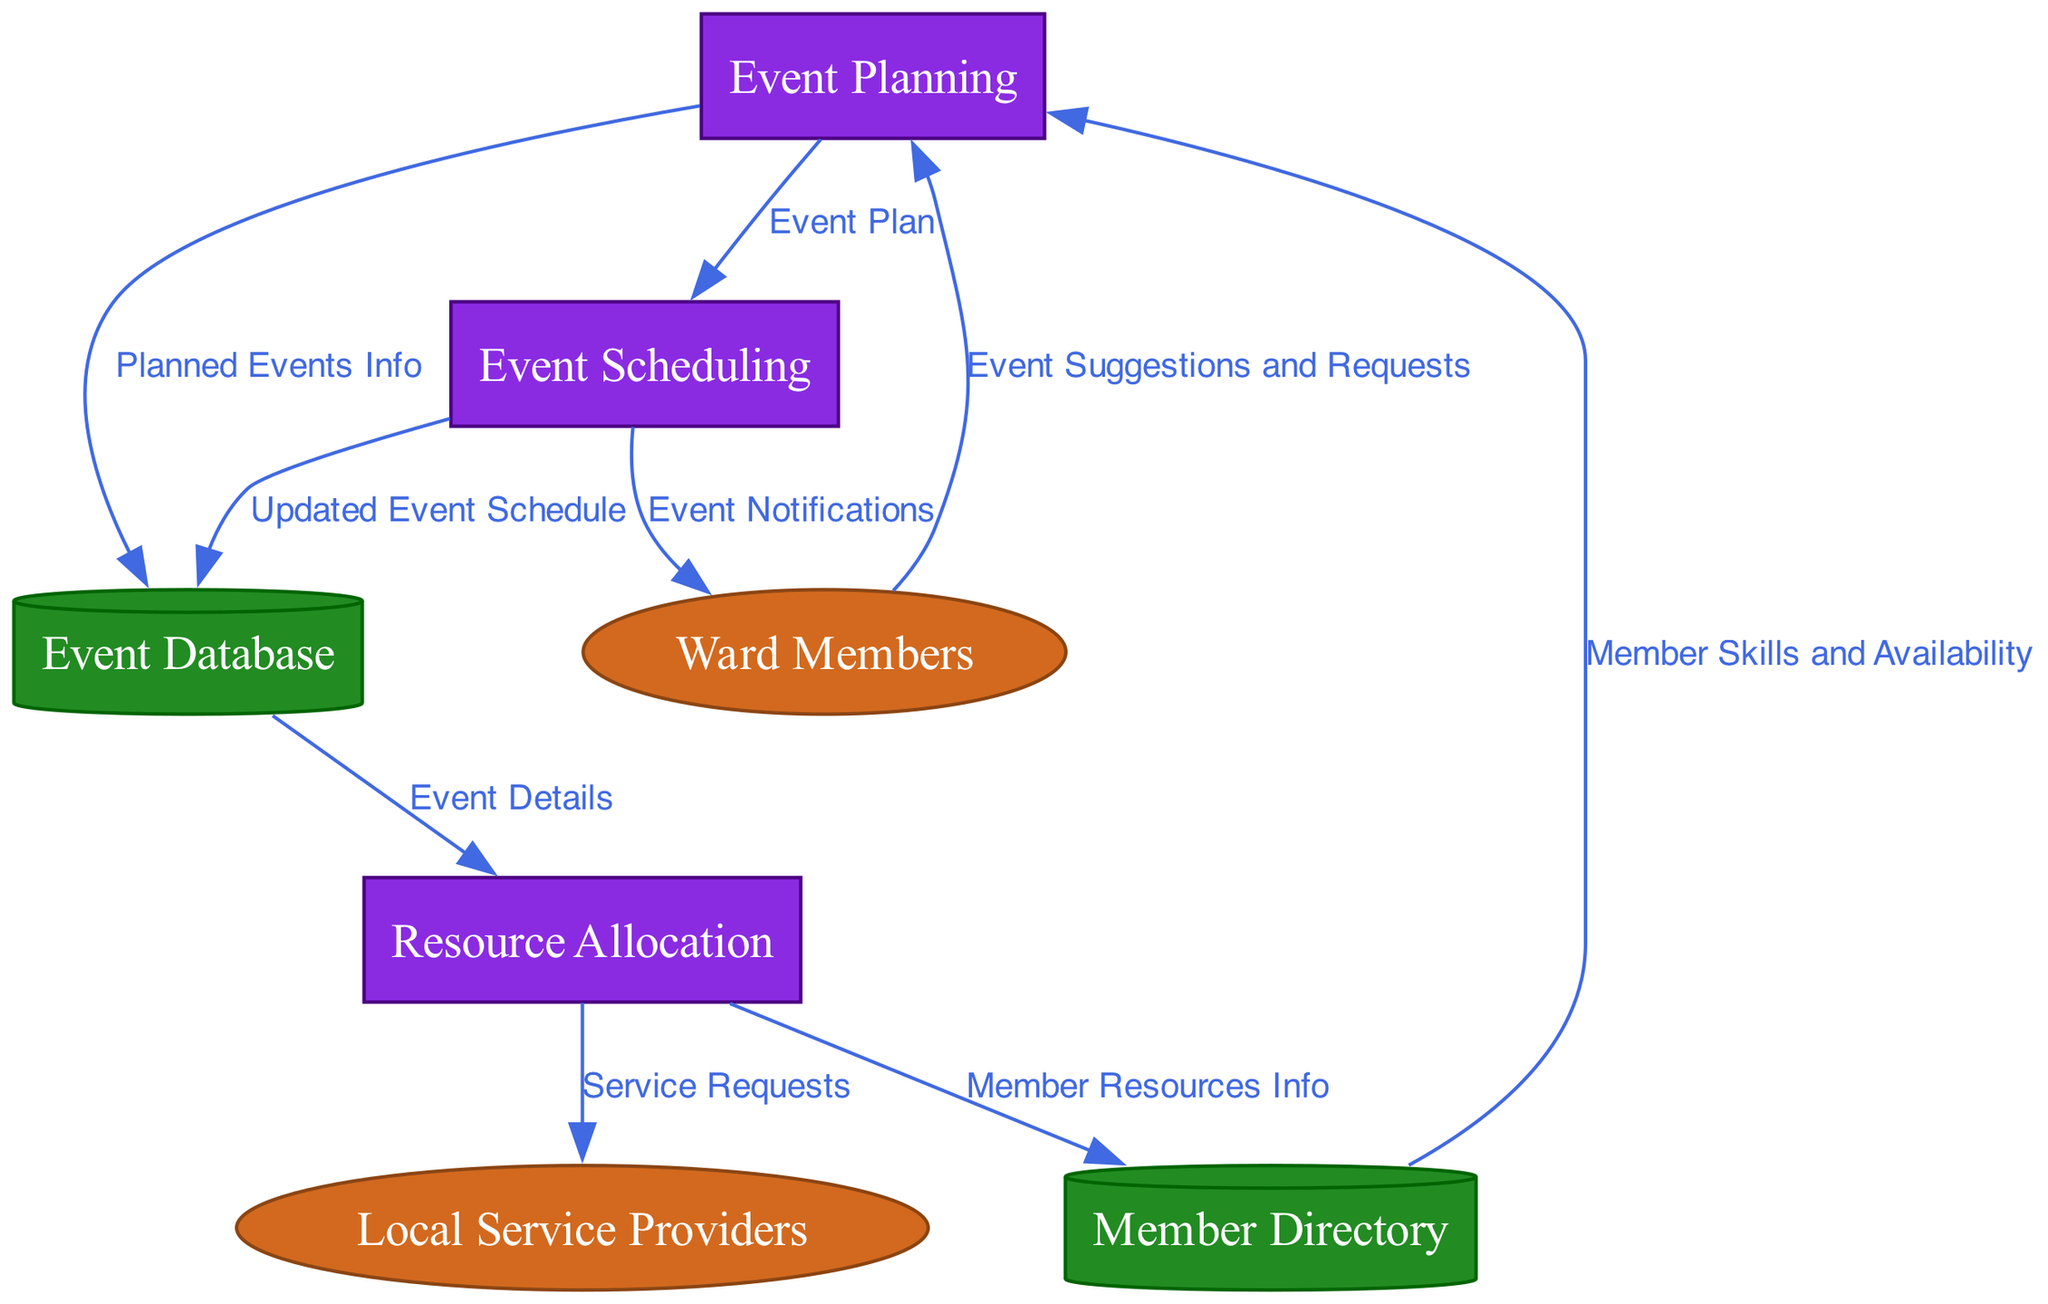What are the names of the external entities in the diagram? The diagram contains two external entities: Ward Members and Local Service Providers. These names are directly listed in the external entities section of the diagram.
Answer: Ward Members, Local Service Providers How many processes are represented in the diagram? The diagram shows three processes: Event Planning, Resource Allocation, and Event Scheduling. Since these are the only processes that are listed, the total is three.
Answer: 3 What is the data flow from Ward Members to the Event Planning process? The data flow from Ward Members to the Event Planning process is named "Event Suggestions and Requests." This information can be found in the data flows section of the diagram.
Answer: Event Suggestions and Requests Which data store receives information from the Event Scheduling process? The updated Event Schedule flows from the Event Scheduling process to the Event Database. This indicates that the Event Database is the data store that receives the information.
Answer: Event Database What is the purpose of the Resource Allocation process? The Resource Allocation process utilizes Event Details to make Service Requests to Local Service Providers and gather Member Resources Info, indicating its role in coordinating resources for events.
Answer: Coordination of resources How many edges are there flowing into the Event Planning process? There are three edges flowing into the Event Planning process: one from Ward Members, one from the Member Directory, and one to the Event Scheduling process. This totals to three edges.
Answer: 3 What type of information is stored in the Member Directory data store? The Member Directory stores Member Skills and Availability, as indicated by the data flow from the Member Directory to the Event Planning process.
Answer: Member Skills and Availability What happens after the Event Scheduling process? After the Event Scheduling process, an Updated Event Schedule is sent to the Event Database and Event Notifications are sent to the Ward Members. This outlines the immediate actions taken post-scheduling.
Answer: Updated Event Schedule, Event Notifications What does the Resource Allocation process output to the Local Service Providers? The Resource Allocation process outputs Service Requests to the Local Service Providers, instructing them to provide necessary resources for the events.
Answer: Service Requests 